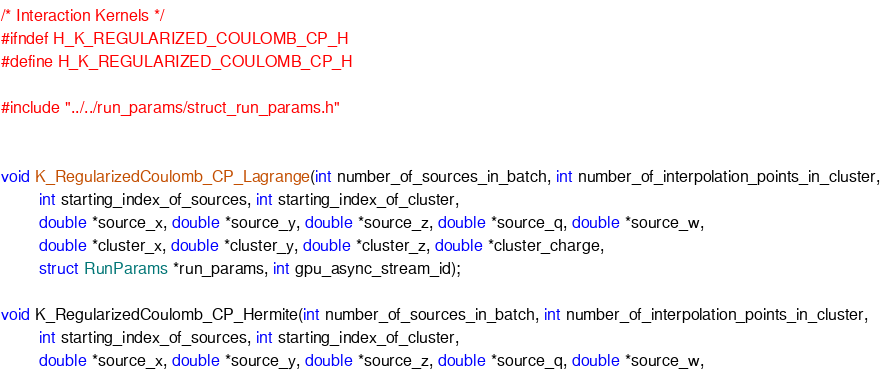Convert code to text. <code><loc_0><loc_0><loc_500><loc_500><_C_>/* Interaction Kernels */
#ifndef H_K_REGULARIZED_COULOMB_CP_H
#define H_K_REGULARIZED_COULOMB_CP_H
 
#include "../../run_params/struct_run_params.h"


void K_RegularizedCoulomb_CP_Lagrange(int number_of_sources_in_batch, int number_of_interpolation_points_in_cluster,
        int starting_index_of_sources, int starting_index_of_cluster,
        double *source_x, double *source_y, double *source_z, double *source_q, double *source_w,
        double *cluster_x, double *cluster_y, double *cluster_z, double *cluster_charge,
        struct RunParams *run_params, int gpu_async_stream_id);

void K_RegularizedCoulomb_CP_Hermite(int number_of_sources_in_batch, int number_of_interpolation_points_in_cluster,
        int starting_index_of_sources, int starting_index_of_cluster,
        double *source_x, double *source_y, double *source_z, double *source_q, double *source_w,</code> 